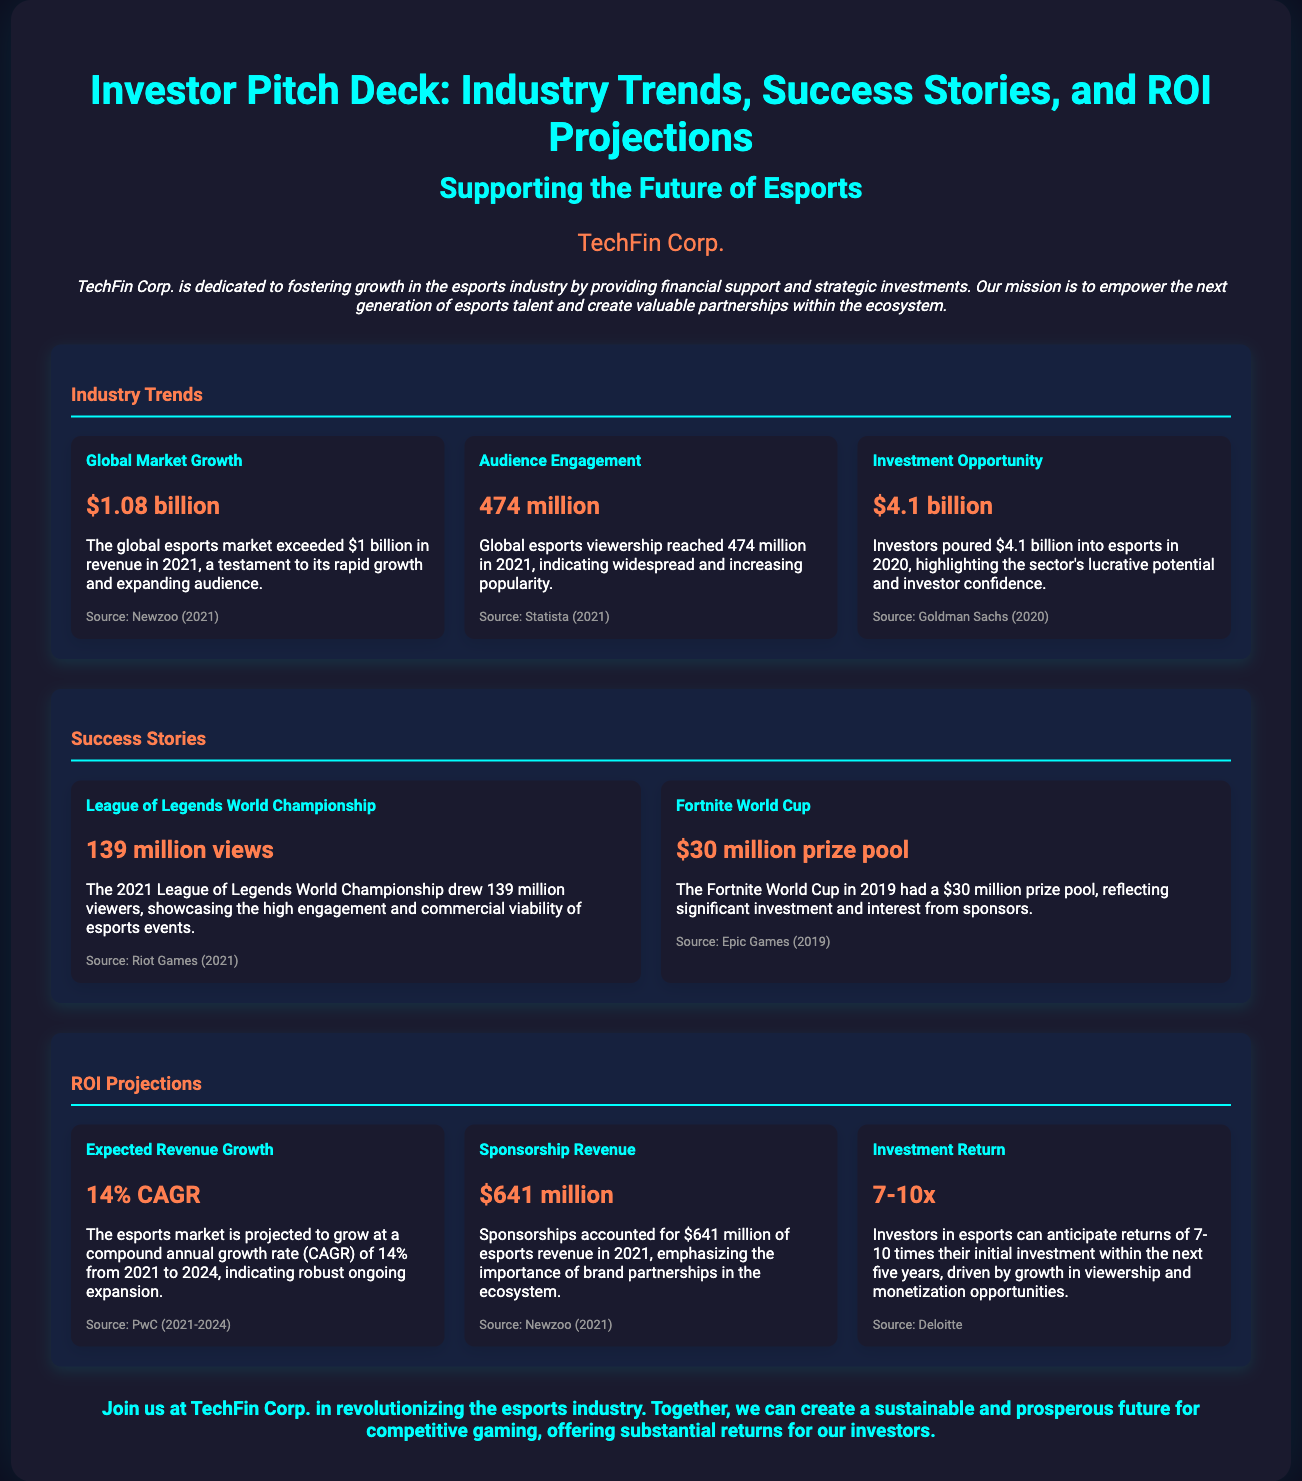What is the global esports market revenue in 2021? The document states that the global esports market exceeded $1 billion in revenue in 2021.
Answer: $1.08 billion How many million viewers did the League of Legends World Championship attract in 2021? The document indicates that the 2021 League of Legends World Championship drew 139 million viewers.
Answer: 139 million views What is the projected CAGR for the esports market from 2021 to 2024? The document mentions that the esports market is projected to grow at a compound annual growth rate of 14% from 2021 to 2024.
Answer: 14% CAGR How much did investors pour into esports in 2020? According to the document, investors poured $4.1 billion into esports in 2020.
Answer: $4.1 billion What was the prize pool for the Fortnite World Cup in 2019? The document states the Fortnite World Cup in 2019 had a prize pool of $30 million.
Answer: $30 million prize pool What is the expected return on investment for esports investors? The document asserts that investors in esports can anticipate returns of 7-10 times their initial investment.
Answer: 7-10x What was the sponsorship revenue of esports in 2021? The document notes that sponsorships accounted for $641 million of esports revenue in 2021.
Answer: $641 million How many million people globally viewed esports in 2021? The document indicates that global esports viewership reached 474 million in 2021.
Answer: 474 million What event is highlighted as having a significant number of views in the success stories? The document emphasizes the League of Legends World Championship for its 139 million views.
Answer: League of Legends World Championship 